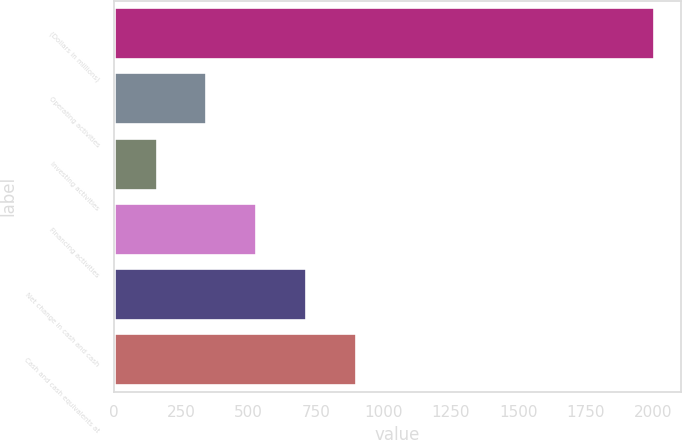Convert chart. <chart><loc_0><loc_0><loc_500><loc_500><bar_chart><fcel>(Dollars in millions)<fcel>Operating activities<fcel>Investing activities<fcel>Financing activities<fcel>Net change in cash and cash<fcel>Cash and cash equivalents at<nl><fcel>2003<fcel>344.3<fcel>160<fcel>528.6<fcel>712.9<fcel>897.2<nl></chart> 